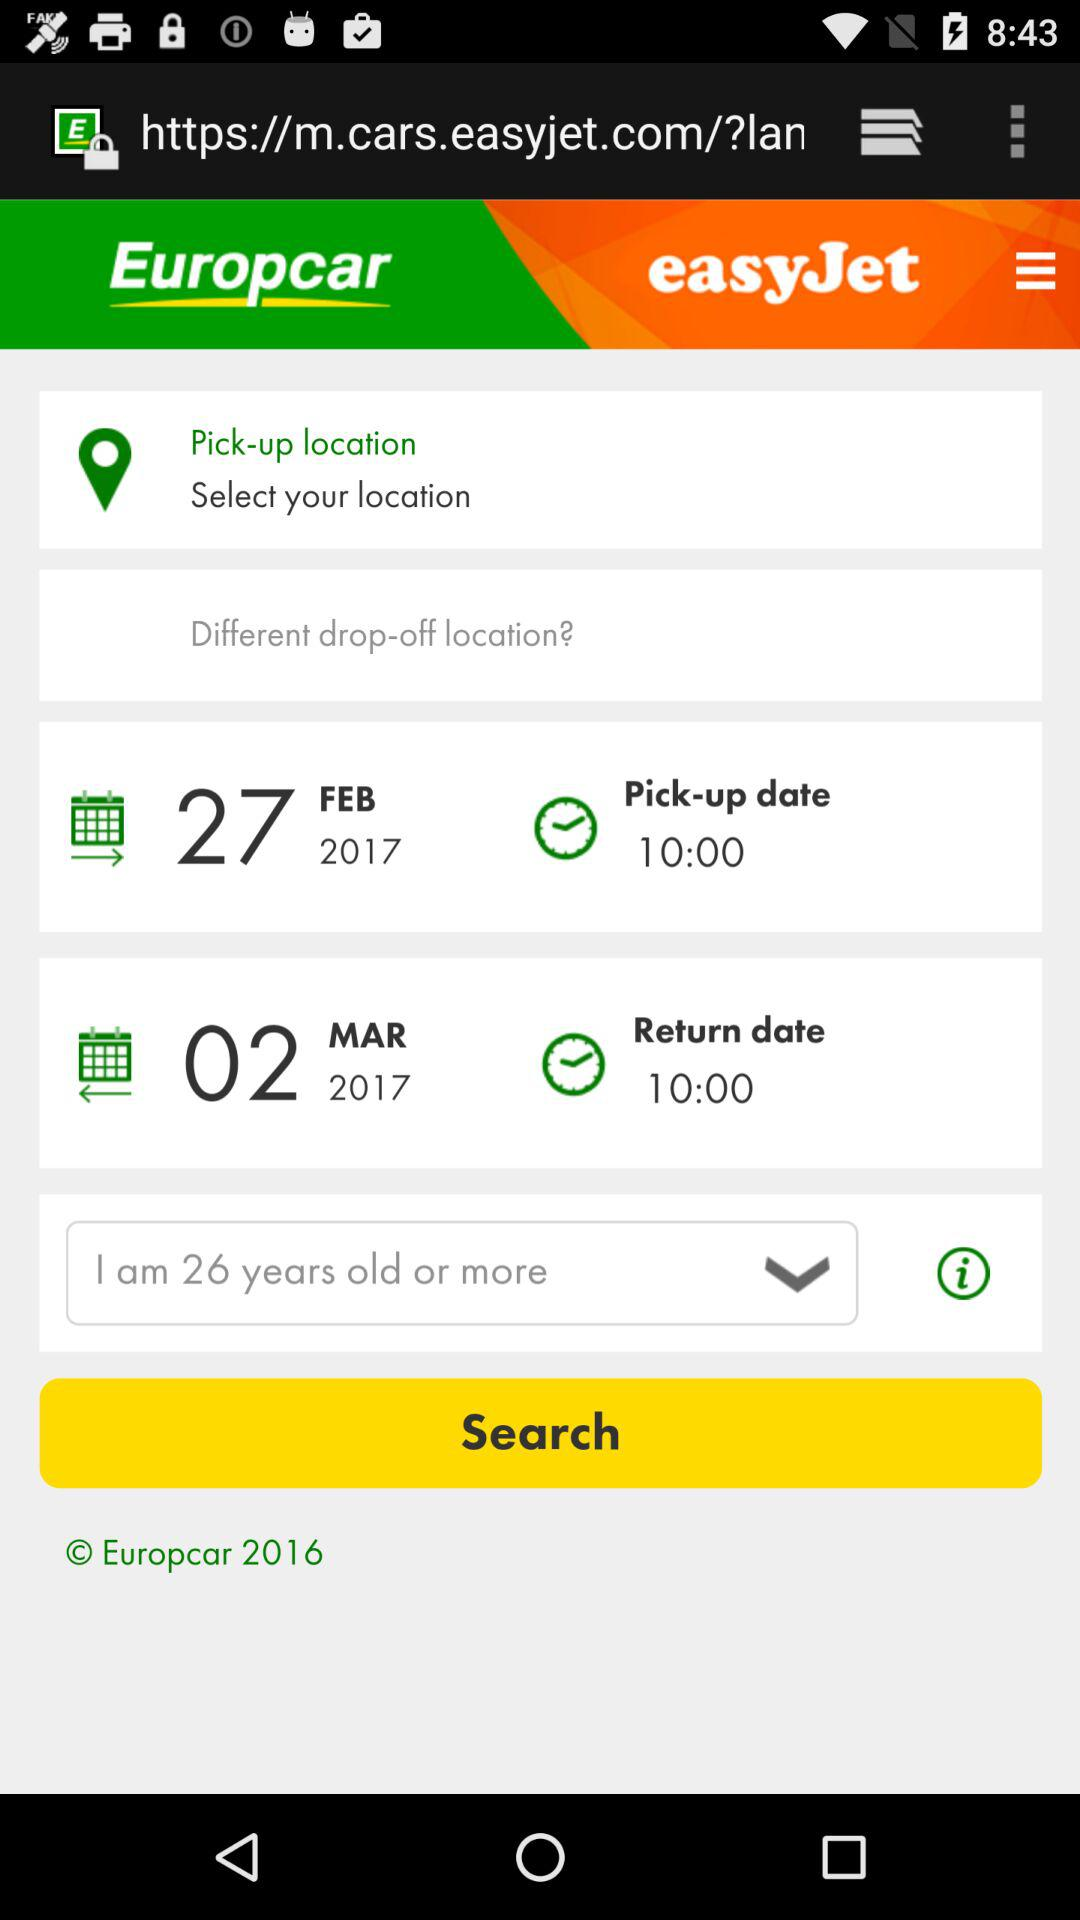What is the year of copyright for the application? The year of copyright for the application is 2016. 